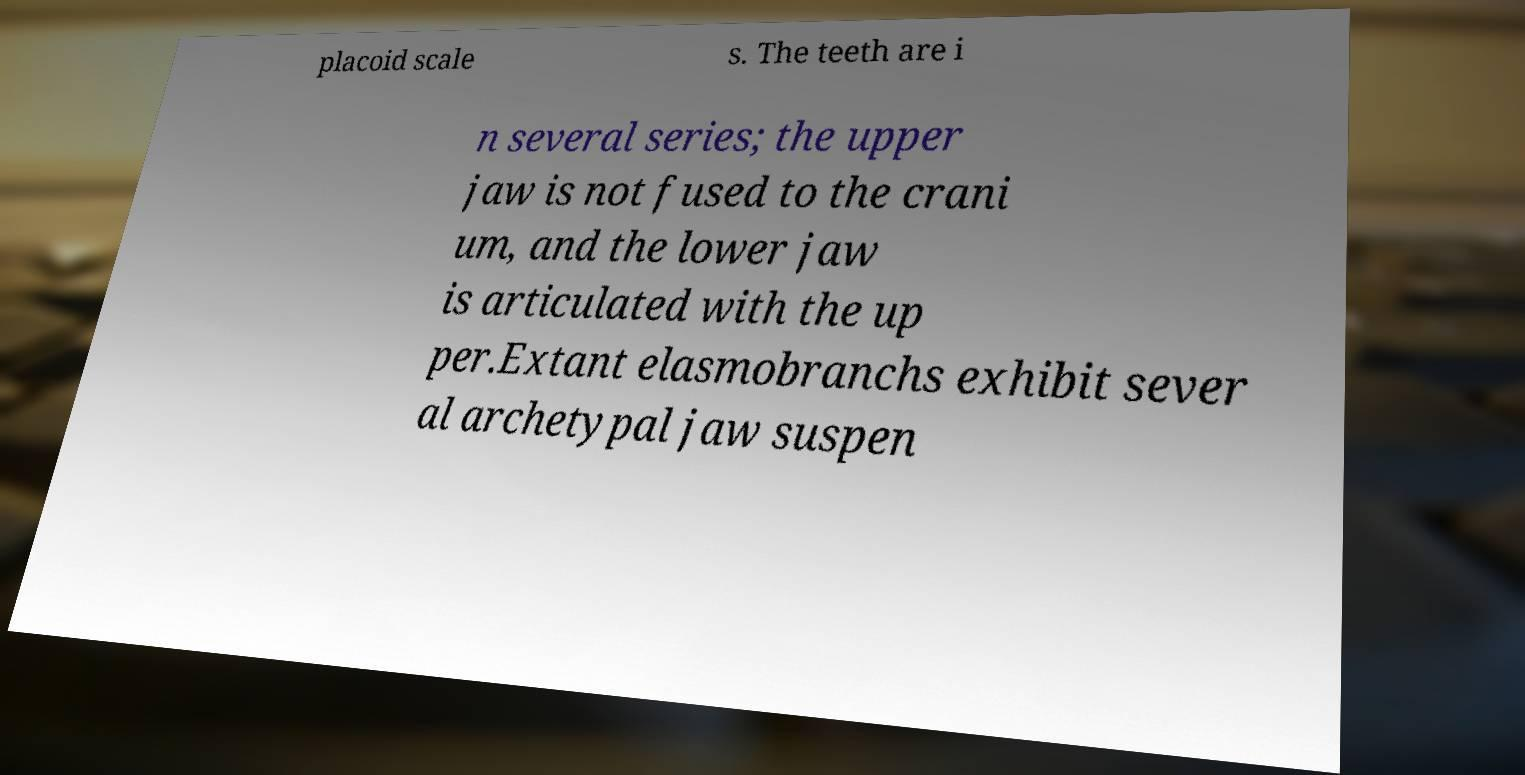Please identify and transcribe the text found in this image. placoid scale s. The teeth are i n several series; the upper jaw is not fused to the crani um, and the lower jaw is articulated with the up per.Extant elasmobranchs exhibit sever al archetypal jaw suspen 